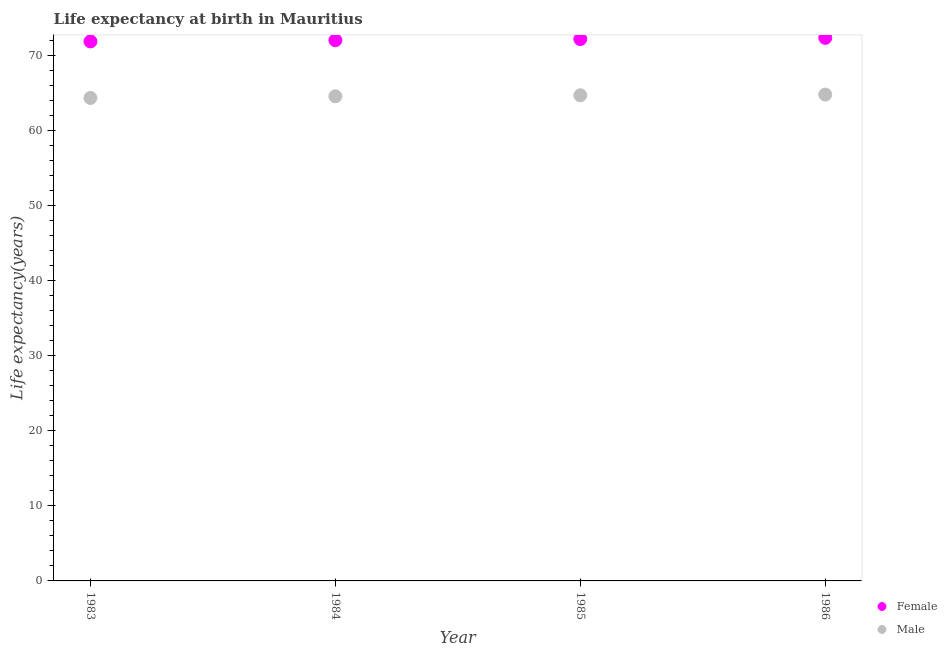How many different coloured dotlines are there?
Ensure brevity in your answer.  2. Is the number of dotlines equal to the number of legend labels?
Keep it short and to the point. Yes. What is the life expectancy(male) in 1985?
Provide a succinct answer. 64.72. Across all years, what is the maximum life expectancy(female)?
Ensure brevity in your answer.  72.37. Across all years, what is the minimum life expectancy(male)?
Keep it short and to the point. 64.36. What is the total life expectancy(female) in the graph?
Provide a short and direct response. 288.53. What is the difference between the life expectancy(male) in 1983 and that in 1984?
Offer a terse response. -0.22. What is the difference between the life expectancy(female) in 1985 and the life expectancy(male) in 1983?
Your response must be concise. 7.84. What is the average life expectancy(female) per year?
Offer a terse response. 72.13. In the year 1985, what is the difference between the life expectancy(male) and life expectancy(female)?
Provide a short and direct response. -7.49. In how many years, is the life expectancy(male) greater than 6 years?
Your answer should be compact. 4. What is the ratio of the life expectancy(male) in 1985 to that in 1986?
Provide a succinct answer. 1. Is the difference between the life expectancy(male) in 1985 and 1986 greater than the difference between the life expectancy(female) in 1985 and 1986?
Give a very brief answer. Yes. What is the difference between the highest and the second highest life expectancy(female)?
Provide a succinct answer. 0.16. What is the difference between the highest and the lowest life expectancy(female)?
Provide a succinct answer. 0.47. Is the life expectancy(female) strictly greater than the life expectancy(male) over the years?
Provide a short and direct response. Yes. How many years are there in the graph?
Give a very brief answer. 4. What is the difference between two consecutive major ticks on the Y-axis?
Ensure brevity in your answer.  10. Does the graph contain any zero values?
Make the answer very short. No. Does the graph contain grids?
Offer a very short reply. No. Where does the legend appear in the graph?
Keep it short and to the point. Bottom right. How are the legend labels stacked?
Keep it short and to the point. Vertical. What is the title of the graph?
Keep it short and to the point. Life expectancy at birth in Mauritius. Does "Non-residents" appear as one of the legend labels in the graph?
Keep it short and to the point. No. What is the label or title of the X-axis?
Provide a short and direct response. Year. What is the label or title of the Y-axis?
Provide a short and direct response. Life expectancy(years). What is the Life expectancy(years) of Female in 1983?
Your response must be concise. 71.9. What is the Life expectancy(years) in Male in 1983?
Ensure brevity in your answer.  64.36. What is the Life expectancy(years) in Female in 1984?
Make the answer very short. 72.06. What is the Life expectancy(years) of Male in 1984?
Offer a terse response. 64.58. What is the Life expectancy(years) of Female in 1985?
Offer a very short reply. 72.21. What is the Life expectancy(years) in Male in 1985?
Offer a terse response. 64.72. What is the Life expectancy(years) of Female in 1986?
Make the answer very short. 72.37. What is the Life expectancy(years) in Male in 1986?
Your response must be concise. 64.81. Across all years, what is the maximum Life expectancy(years) of Female?
Provide a short and direct response. 72.37. Across all years, what is the maximum Life expectancy(years) in Male?
Give a very brief answer. 64.81. Across all years, what is the minimum Life expectancy(years) in Female?
Provide a short and direct response. 71.9. Across all years, what is the minimum Life expectancy(years) in Male?
Your response must be concise. 64.36. What is the total Life expectancy(years) of Female in the graph?
Your response must be concise. 288.53. What is the total Life expectancy(years) in Male in the graph?
Your answer should be compact. 258.48. What is the difference between the Life expectancy(years) of Female in 1983 and that in 1984?
Ensure brevity in your answer.  -0.16. What is the difference between the Life expectancy(years) in Male in 1983 and that in 1984?
Your response must be concise. -0.22. What is the difference between the Life expectancy(years) of Female in 1983 and that in 1985?
Make the answer very short. -0.31. What is the difference between the Life expectancy(years) in Male in 1983 and that in 1985?
Provide a succinct answer. -0.36. What is the difference between the Life expectancy(years) in Female in 1983 and that in 1986?
Make the answer very short. -0.47. What is the difference between the Life expectancy(years) in Male in 1983 and that in 1986?
Make the answer very short. -0.45. What is the difference between the Life expectancy(years) of Female in 1984 and that in 1985?
Your answer should be very brief. -0.15. What is the difference between the Life expectancy(years) in Male in 1984 and that in 1985?
Your answer should be compact. -0.13. What is the difference between the Life expectancy(years) in Female in 1984 and that in 1986?
Offer a very short reply. -0.31. What is the difference between the Life expectancy(years) of Male in 1984 and that in 1986?
Provide a succinct answer. -0.23. What is the difference between the Life expectancy(years) of Female in 1985 and that in 1986?
Provide a succinct answer. -0.16. What is the difference between the Life expectancy(years) in Male in 1985 and that in 1986?
Offer a very short reply. -0.1. What is the difference between the Life expectancy(years) of Female in 1983 and the Life expectancy(years) of Male in 1984?
Provide a short and direct response. 7.31. What is the difference between the Life expectancy(years) of Female in 1983 and the Life expectancy(years) of Male in 1985?
Give a very brief answer. 7.18. What is the difference between the Life expectancy(years) of Female in 1983 and the Life expectancy(years) of Male in 1986?
Give a very brief answer. 7.08. What is the difference between the Life expectancy(years) of Female in 1984 and the Life expectancy(years) of Male in 1985?
Provide a short and direct response. 7.34. What is the difference between the Life expectancy(years) of Female in 1984 and the Life expectancy(years) of Male in 1986?
Provide a short and direct response. 7.24. What is the difference between the Life expectancy(years) in Female in 1985 and the Life expectancy(years) in Male in 1986?
Offer a terse response. 7.39. What is the average Life expectancy(years) in Female per year?
Make the answer very short. 72.13. What is the average Life expectancy(years) in Male per year?
Offer a very short reply. 64.62. In the year 1983, what is the difference between the Life expectancy(years) of Female and Life expectancy(years) of Male?
Your answer should be compact. 7.54. In the year 1984, what is the difference between the Life expectancy(years) of Female and Life expectancy(years) of Male?
Offer a terse response. 7.47. In the year 1985, what is the difference between the Life expectancy(years) in Female and Life expectancy(years) in Male?
Provide a succinct answer. 7.49. In the year 1986, what is the difference between the Life expectancy(years) in Female and Life expectancy(years) in Male?
Your response must be concise. 7.55. What is the ratio of the Life expectancy(years) of Female in 1983 to that in 1985?
Your answer should be very brief. 1. What is the ratio of the Life expectancy(years) in Male in 1983 to that in 1986?
Your answer should be very brief. 0.99. What is the ratio of the Life expectancy(years) in Male in 1984 to that in 1985?
Provide a succinct answer. 1. What is the ratio of the Life expectancy(years) of Female in 1984 to that in 1986?
Provide a short and direct response. 1. What is the difference between the highest and the second highest Life expectancy(years) of Female?
Provide a short and direct response. 0.16. What is the difference between the highest and the second highest Life expectancy(years) of Male?
Keep it short and to the point. 0.1. What is the difference between the highest and the lowest Life expectancy(years) in Female?
Offer a terse response. 0.47. What is the difference between the highest and the lowest Life expectancy(years) in Male?
Your response must be concise. 0.45. 